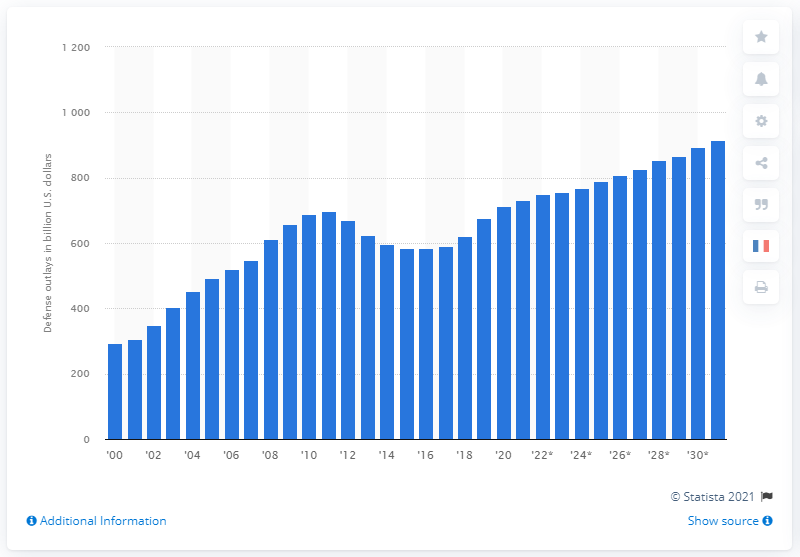Give some essential details in this illustration. In 2020, the amount of defense spending in the United States was 714. The estimated increase in defense outlays in the United States in 2031 will be approximately 915. 